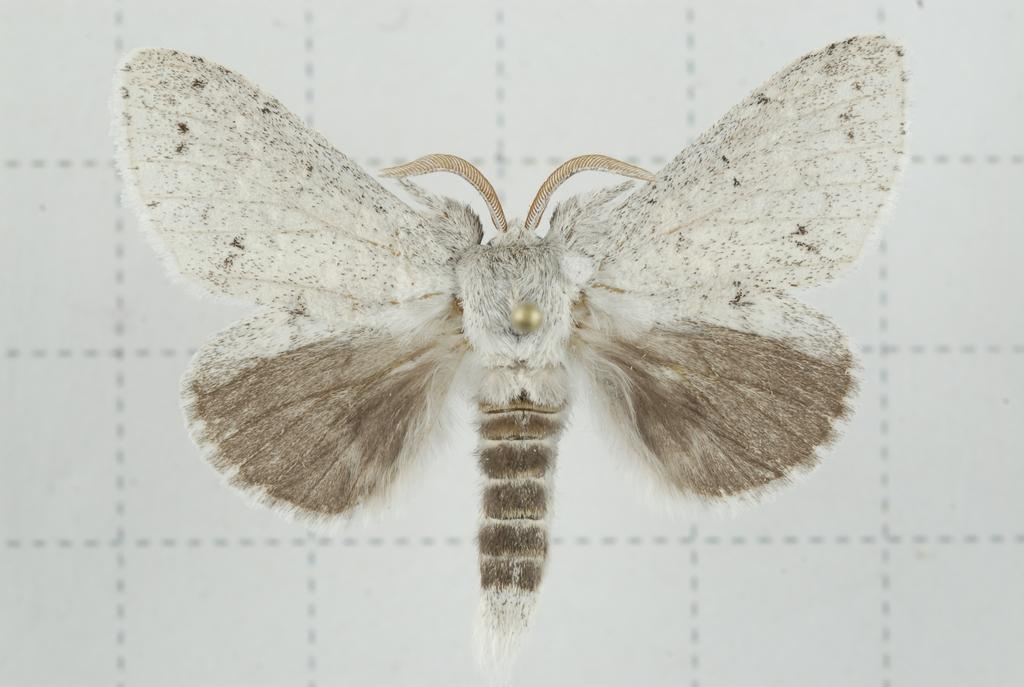What is present on the wall in the image? There is an insect on the wall in the image. How many cards are being used to build a structure with sticks in the image? There are no cards or sticks present in the image; it only features an insect on a wall. 